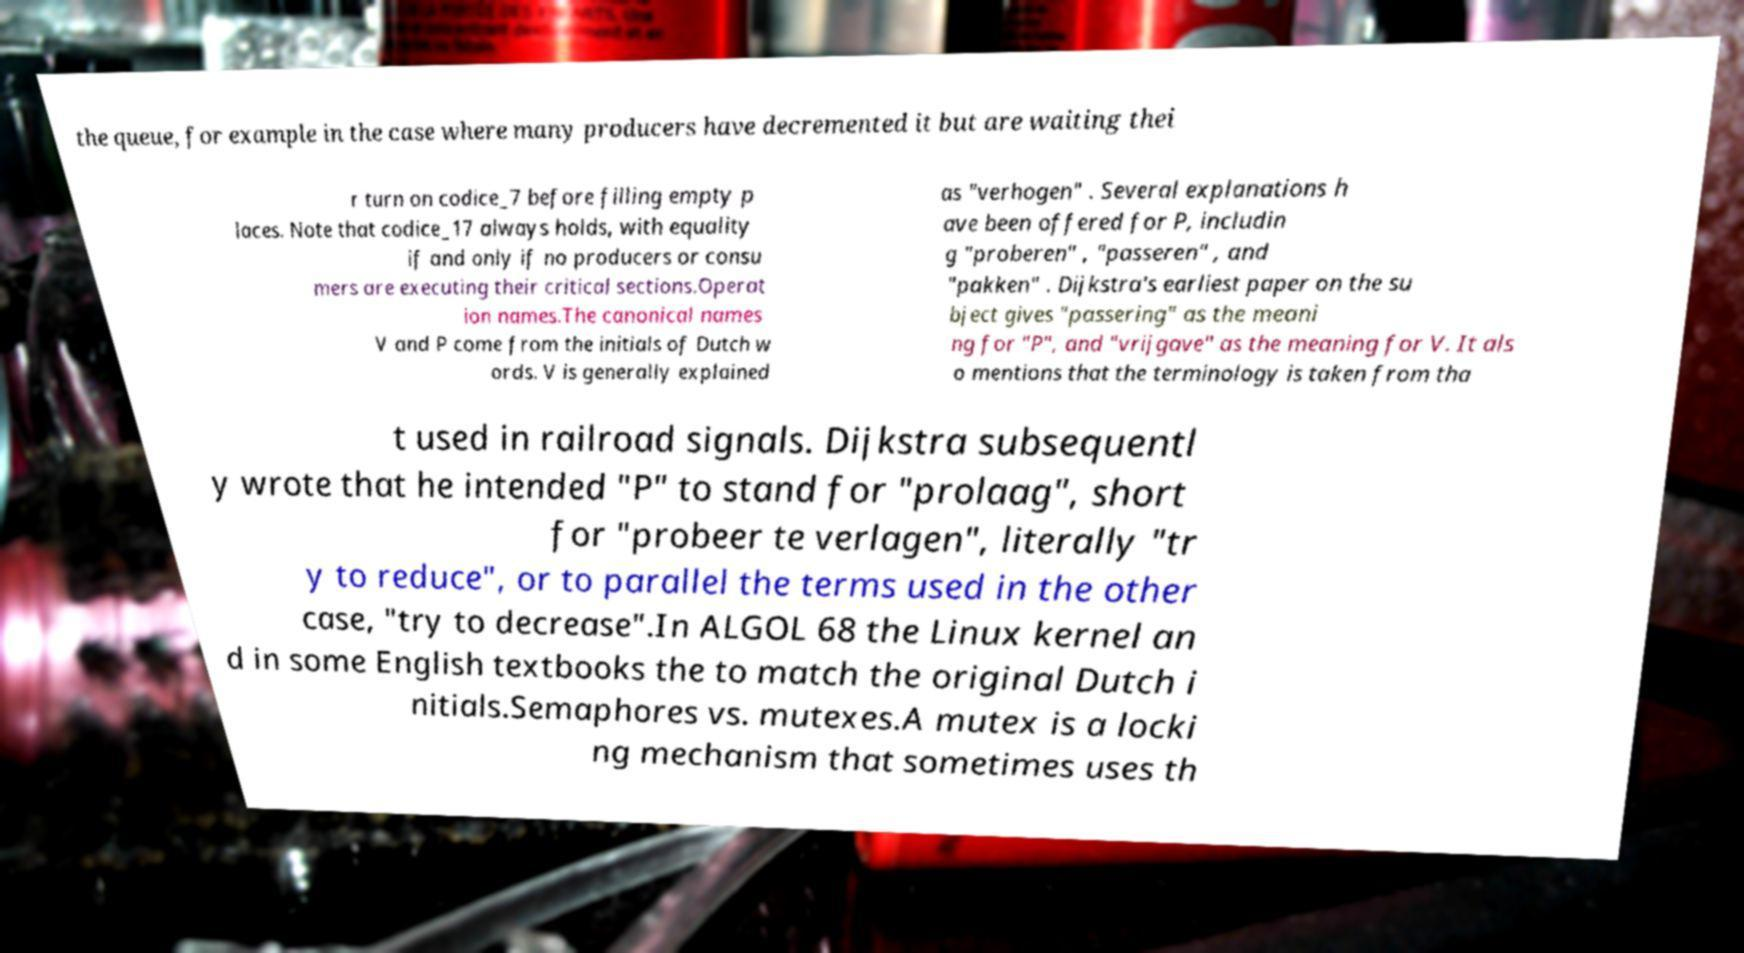I need the written content from this picture converted into text. Can you do that? the queue, for example in the case where many producers have decremented it but are waiting thei r turn on codice_7 before filling empty p laces. Note that codice_17 always holds, with equality if and only if no producers or consu mers are executing their critical sections.Operat ion names.The canonical names V and P come from the initials of Dutch w ords. V is generally explained as "verhogen" . Several explanations h ave been offered for P, includin g "proberen" , "passeren" , and "pakken" . Dijkstra's earliest paper on the su bject gives "passering" as the meani ng for "P", and "vrijgave" as the meaning for V. It als o mentions that the terminology is taken from tha t used in railroad signals. Dijkstra subsequentl y wrote that he intended "P" to stand for "prolaag", short for "probeer te verlagen", literally "tr y to reduce", or to parallel the terms used in the other case, "try to decrease".In ALGOL 68 the Linux kernel an d in some English textbooks the to match the original Dutch i nitials.Semaphores vs. mutexes.A mutex is a locki ng mechanism that sometimes uses th 